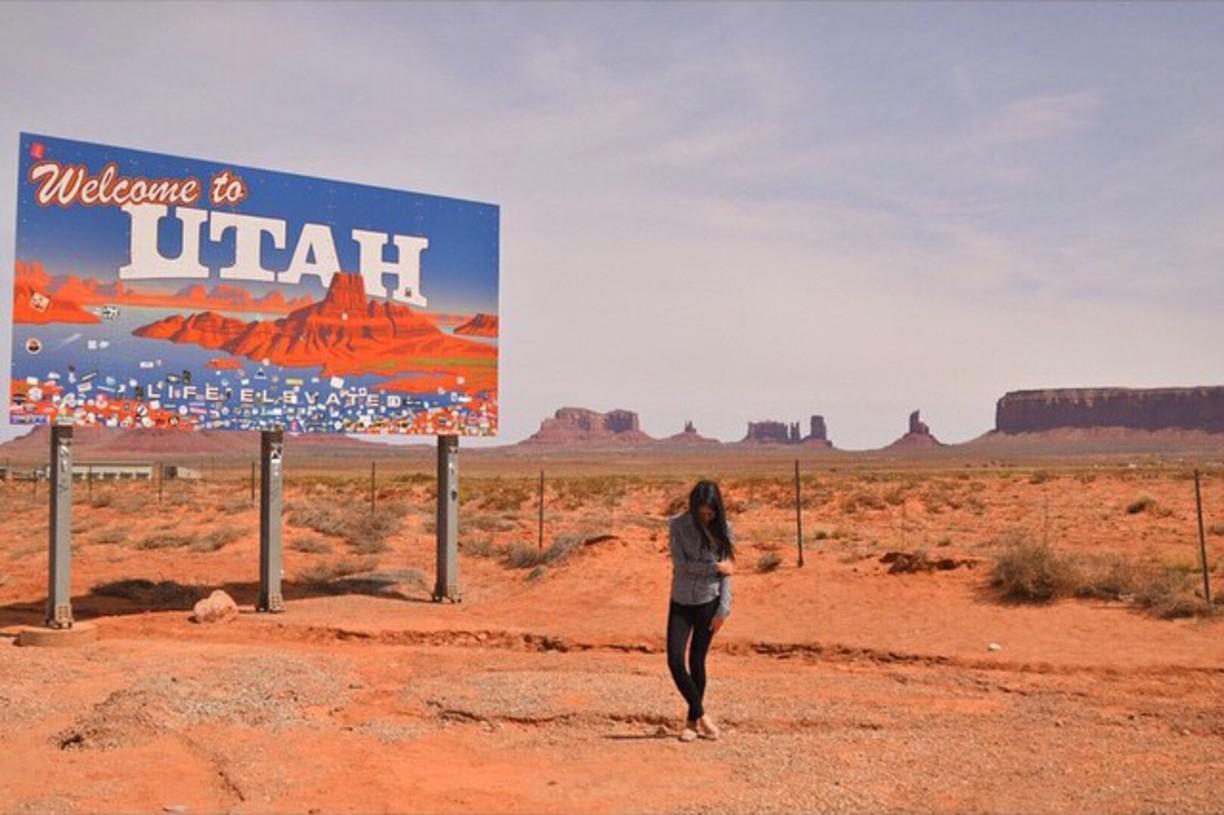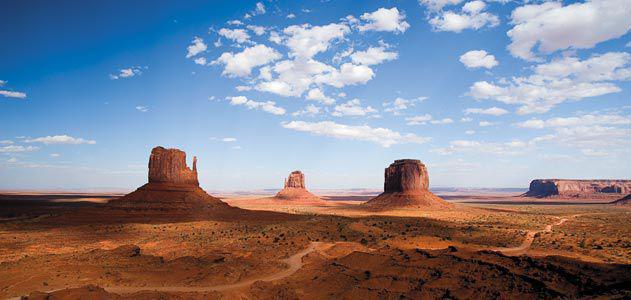The first image is the image on the left, the second image is the image on the right. Examine the images to the left and right. Is the description "The left and right images show the same view of three rock formations, but under different sky conditions." accurate? Answer yes or no. No. The first image is the image on the left, the second image is the image on the right. Given the left and right images, does the statement "In the left image, there is an upright object in the foreground with rock formations behind." hold true? Answer yes or no. Yes. 